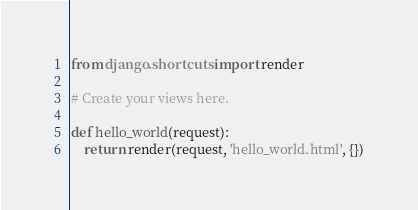<code> <loc_0><loc_0><loc_500><loc_500><_Python_>from django.shortcuts import render

# Create your views here.

def hello_world(request):
    return render(request, 'hello_world.html', {})</code> 